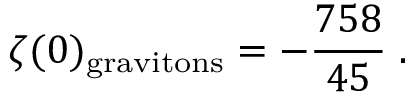Convert formula to latex. <formula><loc_0><loc_0><loc_500><loc_500>\zeta ( 0 ) _ { g r a v i t o n s } = - { \frac { 7 5 8 } { 4 5 } } \, .</formula> 